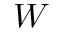<formula> <loc_0><loc_0><loc_500><loc_500>W</formula> 